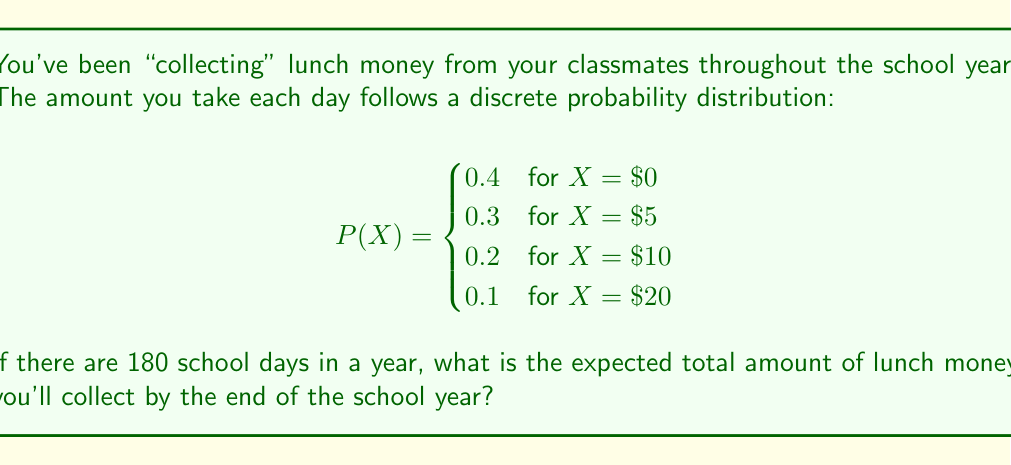Show me your answer to this math problem. To solve this problem, we need to follow these steps:

1) First, calculate the expected value (E[X]) for a single day:
   $$E[X] = \sum_{i} x_i \cdot P(X = x_i)$$
   
   $$E[X] = 0 \cdot 0.4 + 5 \cdot 0.3 + 10 \cdot 0.2 + 20 \cdot 0.1$$
   $$E[X] = 0 + 1.5 + 2 + 2 = 5.5$$

   So, on average, you expect to collect $5.50 per day.

2) To find the expected total for the school year, multiply the daily expected value by the number of school days:

   $$E[\text{Total}] = E[X] \cdot 180$$
   $$E[\text{Total}] = 5.5 \cdot 180 = 990$$

Therefore, the expected total amount of lunch money collected over the 180-day school year is $990.
Answer: $990 